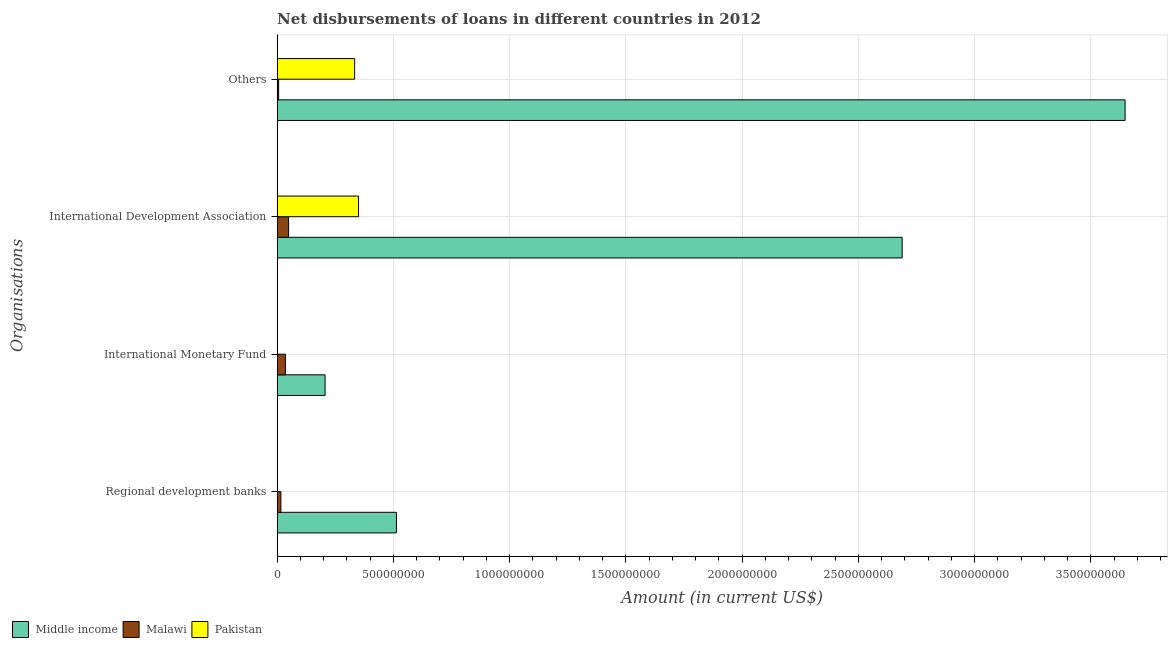How many different coloured bars are there?
Offer a terse response. 3. How many groups of bars are there?
Ensure brevity in your answer.  4. Are the number of bars per tick equal to the number of legend labels?
Give a very brief answer. No. Are the number of bars on each tick of the Y-axis equal?
Give a very brief answer. No. How many bars are there on the 1st tick from the bottom?
Offer a terse response. 2. What is the label of the 3rd group of bars from the top?
Your response must be concise. International Monetary Fund. What is the amount of loan disimbursed by international development association in Middle income?
Give a very brief answer. 2.69e+09. Across all countries, what is the maximum amount of loan disimbursed by other organisations?
Your answer should be very brief. 3.65e+09. Across all countries, what is the minimum amount of loan disimbursed by other organisations?
Provide a short and direct response. 6.55e+06. In which country was the amount of loan disimbursed by regional development banks maximum?
Your response must be concise. Middle income. What is the total amount of loan disimbursed by international development association in the graph?
Your answer should be very brief. 3.09e+09. What is the difference between the amount of loan disimbursed by international monetary fund in Malawi and that in Middle income?
Keep it short and to the point. -1.70e+08. What is the difference between the amount of loan disimbursed by international monetary fund in Malawi and the amount of loan disimbursed by other organisations in Middle income?
Keep it short and to the point. -3.61e+09. What is the average amount of loan disimbursed by regional development banks per country?
Your response must be concise. 1.76e+08. What is the difference between the amount of loan disimbursed by regional development banks and amount of loan disimbursed by international monetary fund in Middle income?
Keep it short and to the point. 3.07e+08. In how many countries, is the amount of loan disimbursed by international development association greater than 2600000000 US$?
Make the answer very short. 1. What is the ratio of the amount of loan disimbursed by international development association in Malawi to that in Middle income?
Your answer should be compact. 0.02. Is the difference between the amount of loan disimbursed by international development association in Malawi and Pakistan greater than the difference between the amount of loan disimbursed by other organisations in Malawi and Pakistan?
Provide a succinct answer. Yes. What is the difference between the highest and the second highest amount of loan disimbursed by other organisations?
Provide a succinct answer. 3.31e+09. What is the difference between the highest and the lowest amount of loan disimbursed by international monetary fund?
Give a very brief answer. 2.06e+08. Is the sum of the amount of loan disimbursed by international monetary fund in Middle income and Malawi greater than the maximum amount of loan disimbursed by regional development banks across all countries?
Provide a succinct answer. No. Is it the case that in every country, the sum of the amount of loan disimbursed by regional development banks and amount of loan disimbursed by international monetary fund is greater than the sum of amount of loan disimbursed by international development association and amount of loan disimbursed by other organisations?
Provide a short and direct response. No. Is it the case that in every country, the sum of the amount of loan disimbursed by regional development banks and amount of loan disimbursed by international monetary fund is greater than the amount of loan disimbursed by international development association?
Offer a very short reply. No. Are all the bars in the graph horizontal?
Your response must be concise. Yes. How many countries are there in the graph?
Your response must be concise. 3. What is the difference between two consecutive major ticks on the X-axis?
Your response must be concise. 5.00e+08. Are the values on the major ticks of X-axis written in scientific E-notation?
Offer a very short reply. No. Does the graph contain any zero values?
Your answer should be compact. Yes. Where does the legend appear in the graph?
Make the answer very short. Bottom left. How many legend labels are there?
Provide a succinct answer. 3. How are the legend labels stacked?
Your response must be concise. Horizontal. What is the title of the graph?
Offer a terse response. Net disbursements of loans in different countries in 2012. What is the label or title of the Y-axis?
Provide a short and direct response. Organisations. What is the Amount (in current US$) in Middle income in Regional development banks?
Offer a terse response. 5.13e+08. What is the Amount (in current US$) in Malawi in Regional development banks?
Your answer should be compact. 1.62e+07. What is the Amount (in current US$) in Middle income in International Monetary Fund?
Offer a terse response. 2.06e+08. What is the Amount (in current US$) of Malawi in International Monetary Fund?
Provide a short and direct response. 3.57e+07. What is the Amount (in current US$) in Pakistan in International Monetary Fund?
Give a very brief answer. 0. What is the Amount (in current US$) of Middle income in International Development Association?
Provide a succinct answer. 2.69e+09. What is the Amount (in current US$) of Malawi in International Development Association?
Offer a terse response. 4.93e+07. What is the Amount (in current US$) of Pakistan in International Development Association?
Your answer should be very brief. 3.50e+08. What is the Amount (in current US$) in Middle income in Others?
Keep it short and to the point. 3.65e+09. What is the Amount (in current US$) of Malawi in Others?
Your response must be concise. 6.55e+06. What is the Amount (in current US$) of Pakistan in Others?
Provide a short and direct response. 3.33e+08. Across all Organisations, what is the maximum Amount (in current US$) of Middle income?
Your response must be concise. 3.65e+09. Across all Organisations, what is the maximum Amount (in current US$) in Malawi?
Your answer should be very brief. 4.93e+07. Across all Organisations, what is the maximum Amount (in current US$) of Pakistan?
Offer a very short reply. 3.50e+08. Across all Organisations, what is the minimum Amount (in current US$) in Middle income?
Provide a succinct answer. 2.06e+08. Across all Organisations, what is the minimum Amount (in current US$) of Malawi?
Give a very brief answer. 6.55e+06. What is the total Amount (in current US$) of Middle income in the graph?
Keep it short and to the point. 7.05e+09. What is the total Amount (in current US$) of Malawi in the graph?
Provide a succinct answer. 1.08e+08. What is the total Amount (in current US$) in Pakistan in the graph?
Give a very brief answer. 6.84e+08. What is the difference between the Amount (in current US$) in Middle income in Regional development banks and that in International Monetary Fund?
Ensure brevity in your answer.  3.07e+08. What is the difference between the Amount (in current US$) in Malawi in Regional development banks and that in International Monetary Fund?
Your answer should be very brief. -1.96e+07. What is the difference between the Amount (in current US$) in Middle income in Regional development banks and that in International Development Association?
Make the answer very short. -2.17e+09. What is the difference between the Amount (in current US$) of Malawi in Regional development banks and that in International Development Association?
Give a very brief answer. -3.32e+07. What is the difference between the Amount (in current US$) in Middle income in Regional development banks and that in Others?
Offer a very short reply. -3.13e+09. What is the difference between the Amount (in current US$) in Malawi in Regional development banks and that in Others?
Offer a very short reply. 9.62e+06. What is the difference between the Amount (in current US$) of Middle income in International Monetary Fund and that in International Development Association?
Your answer should be compact. -2.48e+09. What is the difference between the Amount (in current US$) in Malawi in International Monetary Fund and that in International Development Association?
Keep it short and to the point. -1.36e+07. What is the difference between the Amount (in current US$) of Middle income in International Monetary Fund and that in Others?
Provide a short and direct response. -3.44e+09. What is the difference between the Amount (in current US$) in Malawi in International Monetary Fund and that in Others?
Give a very brief answer. 2.92e+07. What is the difference between the Amount (in current US$) in Middle income in International Development Association and that in Others?
Offer a terse response. -9.59e+08. What is the difference between the Amount (in current US$) of Malawi in International Development Association and that in Others?
Give a very brief answer. 4.28e+07. What is the difference between the Amount (in current US$) in Pakistan in International Development Association and that in Others?
Give a very brief answer. 1.68e+07. What is the difference between the Amount (in current US$) in Middle income in Regional development banks and the Amount (in current US$) in Malawi in International Monetary Fund?
Your answer should be compact. 4.77e+08. What is the difference between the Amount (in current US$) in Middle income in Regional development banks and the Amount (in current US$) in Malawi in International Development Association?
Give a very brief answer. 4.64e+08. What is the difference between the Amount (in current US$) in Middle income in Regional development banks and the Amount (in current US$) in Pakistan in International Development Association?
Make the answer very short. 1.63e+08. What is the difference between the Amount (in current US$) of Malawi in Regional development banks and the Amount (in current US$) of Pakistan in International Development Association?
Your answer should be very brief. -3.34e+08. What is the difference between the Amount (in current US$) in Middle income in Regional development banks and the Amount (in current US$) in Malawi in Others?
Offer a very short reply. 5.06e+08. What is the difference between the Amount (in current US$) in Middle income in Regional development banks and the Amount (in current US$) in Pakistan in Others?
Your response must be concise. 1.80e+08. What is the difference between the Amount (in current US$) of Malawi in Regional development banks and the Amount (in current US$) of Pakistan in Others?
Keep it short and to the point. -3.17e+08. What is the difference between the Amount (in current US$) in Middle income in International Monetary Fund and the Amount (in current US$) in Malawi in International Development Association?
Offer a terse response. 1.57e+08. What is the difference between the Amount (in current US$) in Middle income in International Monetary Fund and the Amount (in current US$) in Pakistan in International Development Association?
Make the answer very short. -1.44e+08. What is the difference between the Amount (in current US$) in Malawi in International Monetary Fund and the Amount (in current US$) in Pakistan in International Development Association?
Ensure brevity in your answer.  -3.14e+08. What is the difference between the Amount (in current US$) of Middle income in International Monetary Fund and the Amount (in current US$) of Malawi in Others?
Give a very brief answer. 2.00e+08. What is the difference between the Amount (in current US$) of Middle income in International Monetary Fund and the Amount (in current US$) of Pakistan in Others?
Keep it short and to the point. -1.27e+08. What is the difference between the Amount (in current US$) in Malawi in International Monetary Fund and the Amount (in current US$) in Pakistan in Others?
Provide a succinct answer. -2.98e+08. What is the difference between the Amount (in current US$) in Middle income in International Development Association and the Amount (in current US$) in Malawi in Others?
Provide a succinct answer. 2.68e+09. What is the difference between the Amount (in current US$) in Middle income in International Development Association and the Amount (in current US$) in Pakistan in Others?
Provide a short and direct response. 2.35e+09. What is the difference between the Amount (in current US$) in Malawi in International Development Association and the Amount (in current US$) in Pakistan in Others?
Provide a succinct answer. -2.84e+08. What is the average Amount (in current US$) of Middle income per Organisations?
Ensure brevity in your answer.  1.76e+09. What is the average Amount (in current US$) in Malawi per Organisations?
Offer a very short reply. 2.69e+07. What is the average Amount (in current US$) of Pakistan per Organisations?
Offer a very short reply. 1.71e+08. What is the difference between the Amount (in current US$) of Middle income and Amount (in current US$) of Malawi in Regional development banks?
Provide a short and direct response. 4.97e+08. What is the difference between the Amount (in current US$) in Middle income and Amount (in current US$) in Malawi in International Monetary Fund?
Your response must be concise. 1.70e+08. What is the difference between the Amount (in current US$) in Middle income and Amount (in current US$) in Malawi in International Development Association?
Offer a terse response. 2.64e+09. What is the difference between the Amount (in current US$) in Middle income and Amount (in current US$) in Pakistan in International Development Association?
Provide a short and direct response. 2.34e+09. What is the difference between the Amount (in current US$) in Malawi and Amount (in current US$) in Pakistan in International Development Association?
Your answer should be very brief. -3.01e+08. What is the difference between the Amount (in current US$) of Middle income and Amount (in current US$) of Malawi in Others?
Your response must be concise. 3.64e+09. What is the difference between the Amount (in current US$) of Middle income and Amount (in current US$) of Pakistan in Others?
Your response must be concise. 3.31e+09. What is the difference between the Amount (in current US$) in Malawi and Amount (in current US$) in Pakistan in Others?
Offer a terse response. -3.27e+08. What is the ratio of the Amount (in current US$) in Middle income in Regional development banks to that in International Monetary Fund?
Make the answer very short. 2.49. What is the ratio of the Amount (in current US$) of Malawi in Regional development banks to that in International Monetary Fund?
Your answer should be very brief. 0.45. What is the ratio of the Amount (in current US$) of Middle income in Regional development banks to that in International Development Association?
Make the answer very short. 0.19. What is the ratio of the Amount (in current US$) of Malawi in Regional development banks to that in International Development Association?
Your response must be concise. 0.33. What is the ratio of the Amount (in current US$) of Middle income in Regional development banks to that in Others?
Offer a terse response. 0.14. What is the ratio of the Amount (in current US$) of Malawi in Regional development banks to that in Others?
Your answer should be very brief. 2.47. What is the ratio of the Amount (in current US$) in Middle income in International Monetary Fund to that in International Development Association?
Provide a short and direct response. 0.08. What is the ratio of the Amount (in current US$) in Malawi in International Monetary Fund to that in International Development Association?
Ensure brevity in your answer.  0.72. What is the ratio of the Amount (in current US$) in Middle income in International Monetary Fund to that in Others?
Make the answer very short. 0.06. What is the ratio of the Amount (in current US$) in Malawi in International Monetary Fund to that in Others?
Offer a terse response. 5.46. What is the ratio of the Amount (in current US$) in Middle income in International Development Association to that in Others?
Offer a very short reply. 0.74. What is the ratio of the Amount (in current US$) in Malawi in International Development Association to that in Others?
Your response must be concise. 7.54. What is the ratio of the Amount (in current US$) of Pakistan in International Development Association to that in Others?
Offer a very short reply. 1.05. What is the difference between the highest and the second highest Amount (in current US$) in Middle income?
Provide a short and direct response. 9.59e+08. What is the difference between the highest and the second highest Amount (in current US$) of Malawi?
Offer a terse response. 1.36e+07. What is the difference between the highest and the lowest Amount (in current US$) of Middle income?
Provide a short and direct response. 3.44e+09. What is the difference between the highest and the lowest Amount (in current US$) in Malawi?
Offer a very short reply. 4.28e+07. What is the difference between the highest and the lowest Amount (in current US$) in Pakistan?
Your response must be concise. 3.50e+08. 